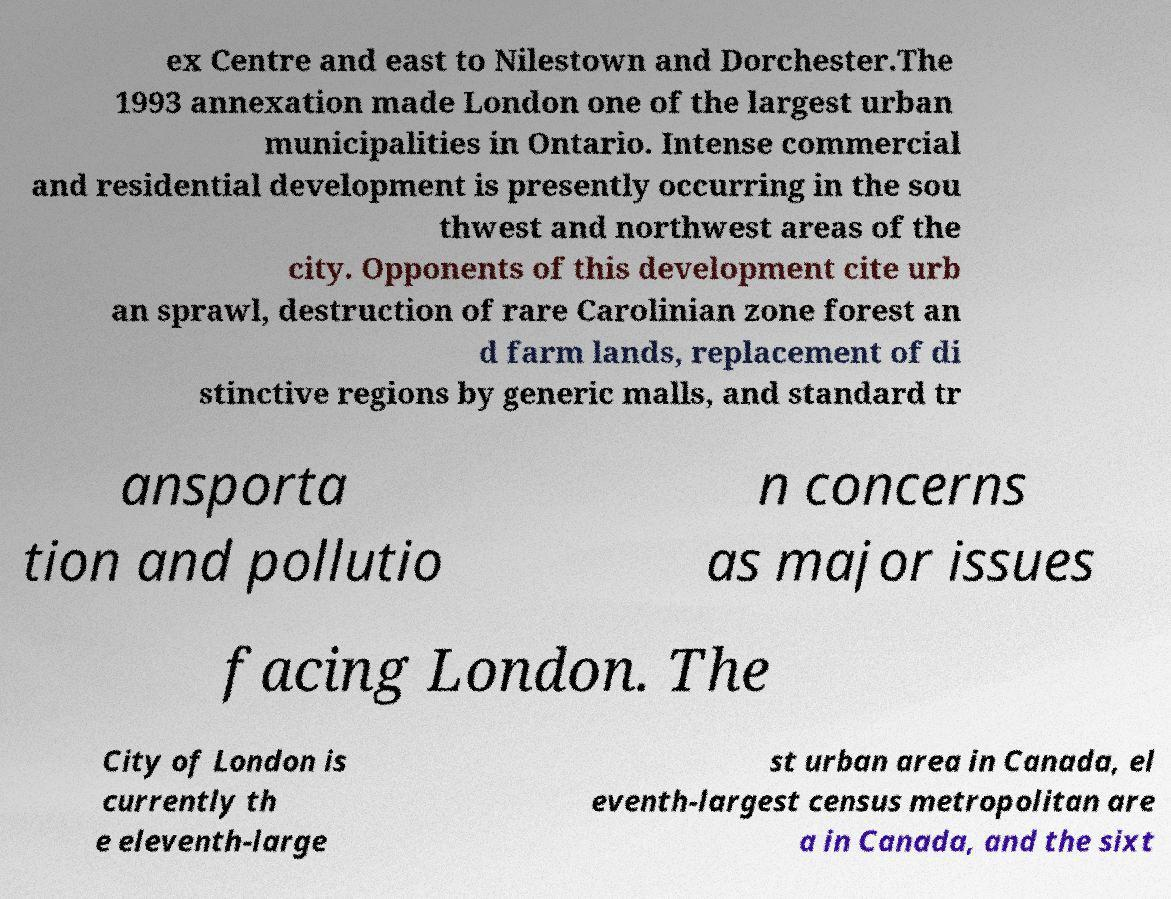Please identify and transcribe the text found in this image. ex Centre and east to Nilestown and Dorchester.The 1993 annexation made London one of the largest urban municipalities in Ontario. Intense commercial and residential development is presently occurring in the sou thwest and northwest areas of the city. Opponents of this development cite urb an sprawl, destruction of rare Carolinian zone forest an d farm lands, replacement of di stinctive regions by generic malls, and standard tr ansporta tion and pollutio n concerns as major issues facing London. The City of London is currently th e eleventh-large st urban area in Canada, el eventh-largest census metropolitan are a in Canada, and the sixt 